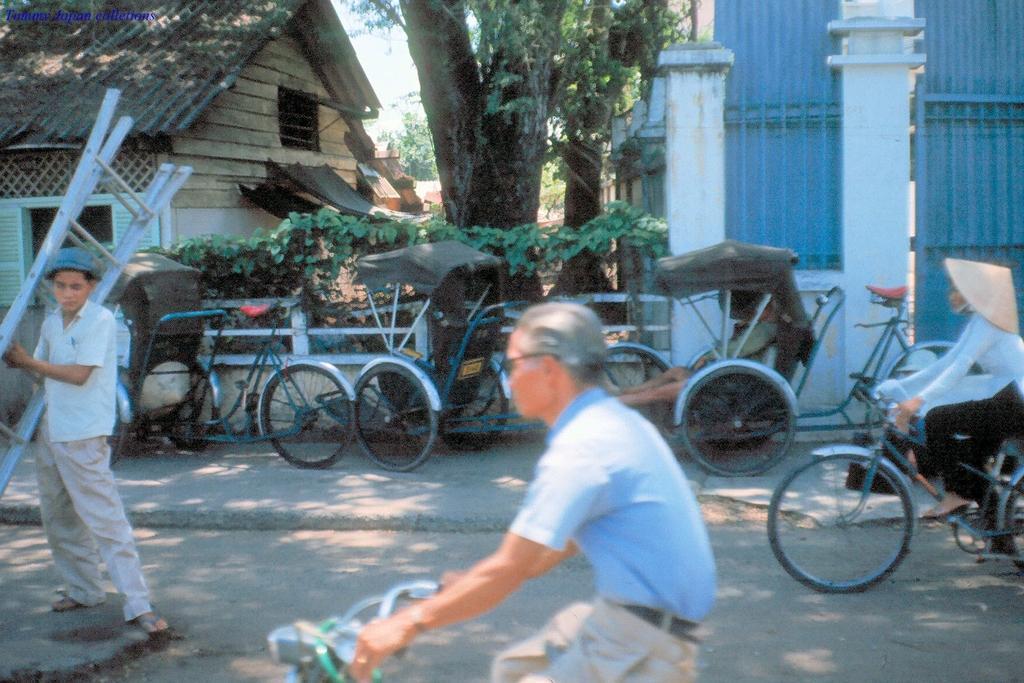Describe this image in one or two sentences. In this picture there are two persons riding bicycle and there is a person standing and holding the ladder. At the back there are buildings, trees and there are vehicles. At the top there is sky. At the bottom there is a road. 